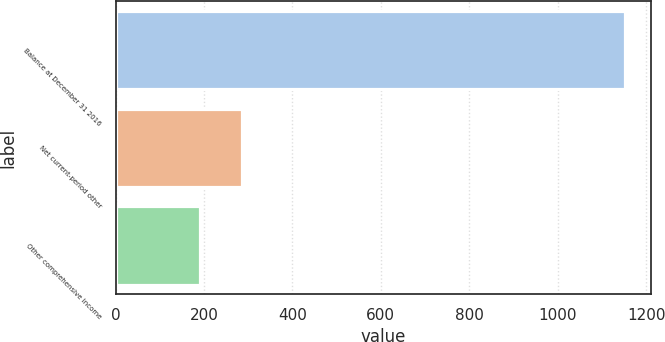Convert chart. <chart><loc_0><loc_0><loc_500><loc_500><bar_chart><fcel>Balance at December 31 2016<fcel>Net current-period other<fcel>Other comprehensive income<nl><fcel>1153<fcel>286.3<fcel>190<nl></chart> 